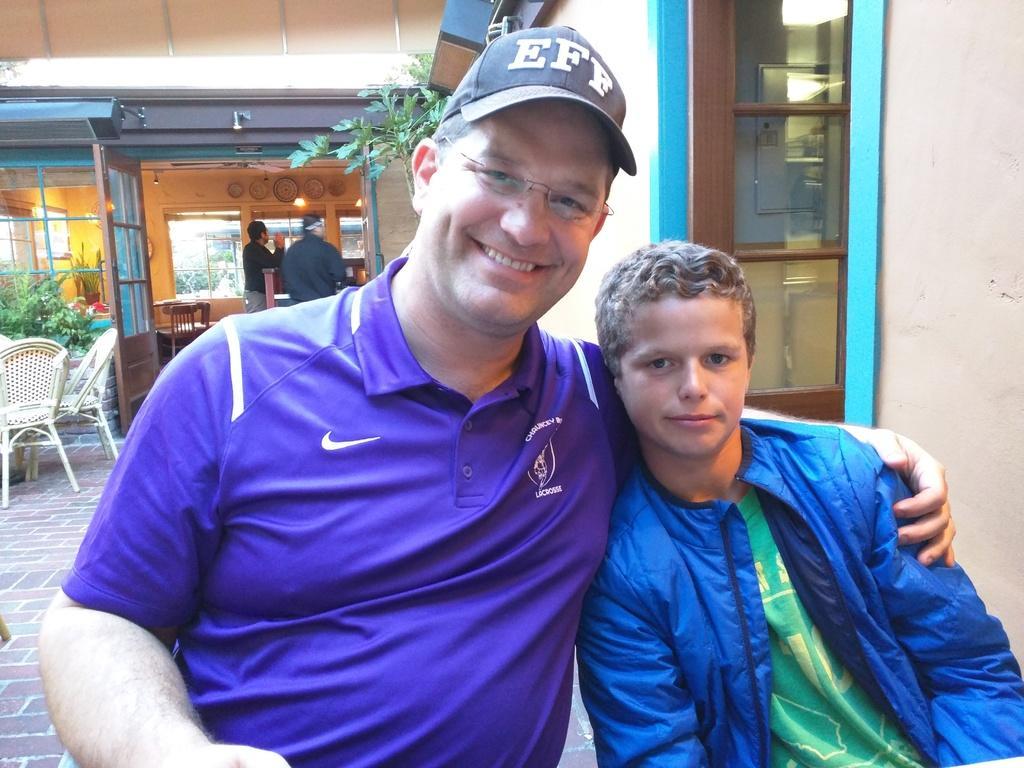Can you describe this image briefly? In this image I can see few people, few plants, few chairs, a building, doors and few lights. I can also see he is wearing specs, a cap and I can see smile on his face. 